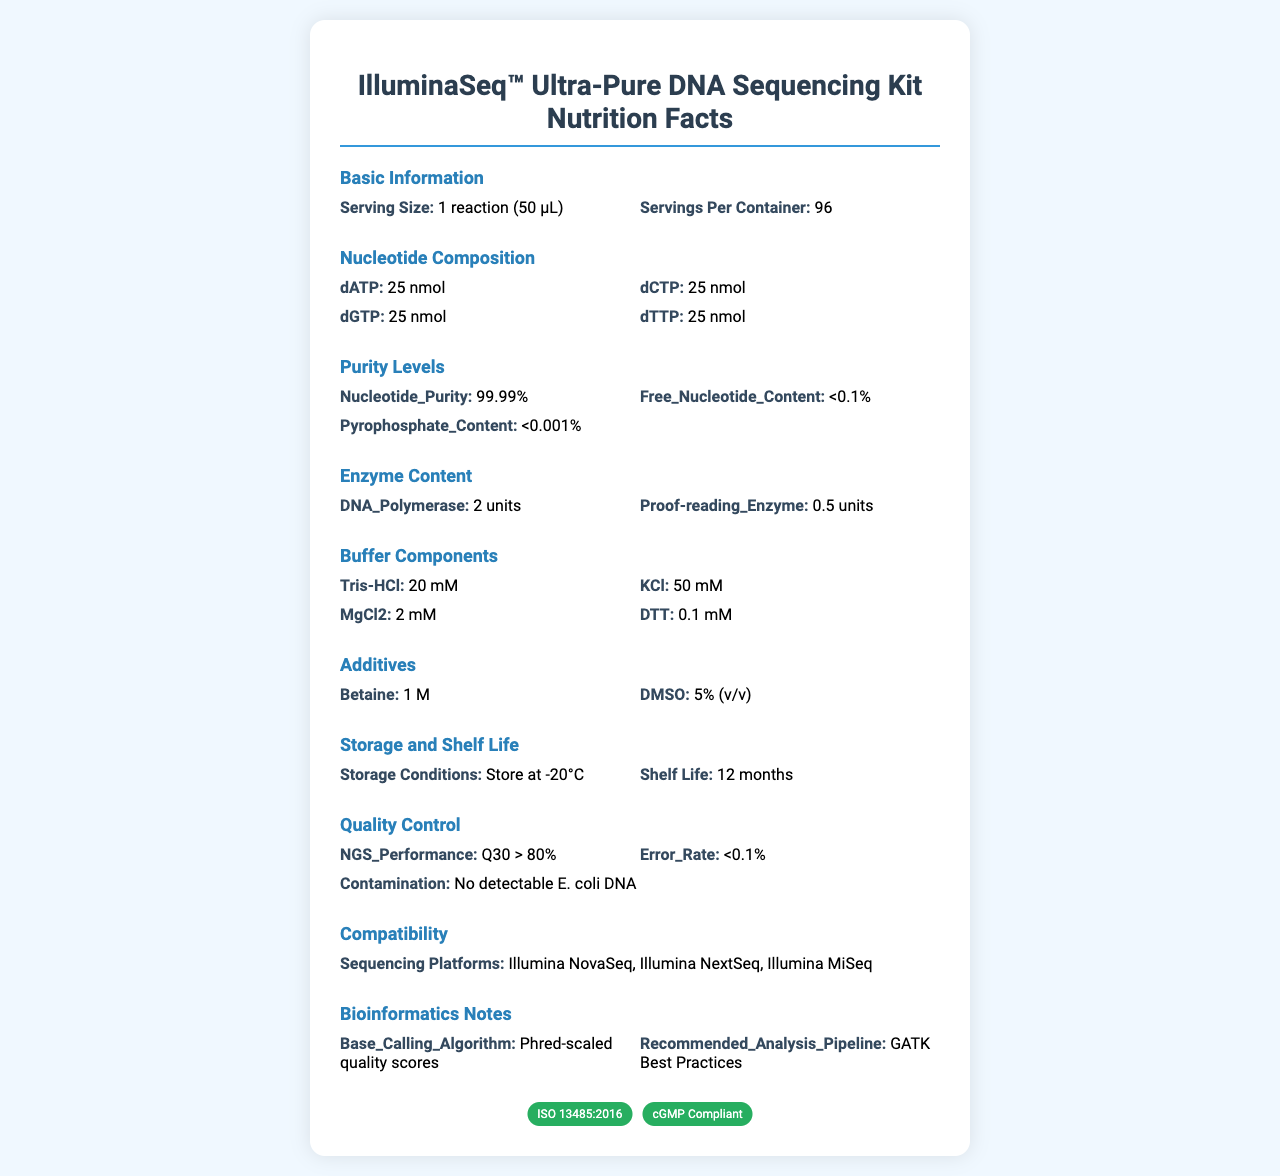what is the serving size? The document states that the serving size is 1 reaction (50 µL).
Answer: 1 reaction (50 µL) How many reactions can you perform with one container of this kit? The document specifies that there are 96 servings per container.
Answer: 96 what is the quantity of dATP in each serving? According to the document, each serving contains 25 nmol of dATP.
Answer: 25 nmol What is the purity level of nucleotides in this kit? The document lists the nucleotide purity as 99.99%.
Answer: 99.99% Which enzyme is present in a higher quantity in each reaction? A. DNA Polymerase B. Proof-reading Enzyme The document states that there are 2 units of DNA Polymerase and 0.5 units of Proof-reading Enzyme, making DNA Polymerase the enzyme present in a higher quantity.
Answer: A. DNA Polymerase What is the error rate maintained in the kit's quality control? Under quality control, the document mentions that the error rate is less than 0.1%.
Answer: <0.1% True or False: The document states that the kit should be stored at -20°C. The storage conditions section of the document specifies that the kit should be stored at -20°C.
Answer: True For how long can the kit be stored while still maintaining its efficacy? The shelf life of the kit, as mentioned in the document, is 12 months.
Answer: 12 months Which sequencing platforms is this kit compatible with? The compatibility section of the document lists these three sequencing platforms.
Answer: Illumina NovaSeq, Illumina NextSeq, Illumina MiSeq What is the content of Tris-HCl in the buffer components? The buffer components section lists Tris-HCl as 20 mM.
Answer: 20 mM Which certification does the kit not have? A. ISO 9001:2015 B. ISO 13485:2016 C. cGMP Compliant The document states that the kit is certified under ISO 13485:2016 and is cGMP compliant but does not mention ISO 9001:2015.
Answer: A. ISO 9001:2015 which betaine concentration does the kit contain? A. 0.5 M B. 1 M C. 2 M The additives section of the document mentions that the concentration of betaine is 1 M.
Answer: B. 1 M Summarize the main information presented in the document. The document provides comprehensive details about the contents and specifications of the DNA Sequencing Kit, including the amount and purity of nucleotides, enzyme and buffer components, storage requirements, shelf life, quality control measures, compatible sequencing platforms, and related certifications.
Answer: The document is a Nutrition Facts Label for the IlluminaSeq™ Ultra-Pure DNA Sequencing Kit. It includes details about serving size, nucleotide composition, purity levels, enzyme content, buffer components, additives, storage conditions, shelf life, quality control standards, compatibility with sequencing platforms, certifications, and bioinformatics notes. What is the glycosylation level of the enzymes? The document does not provide any details regarding the glycosylation level of the enzymes.
Answer: Not enough information 